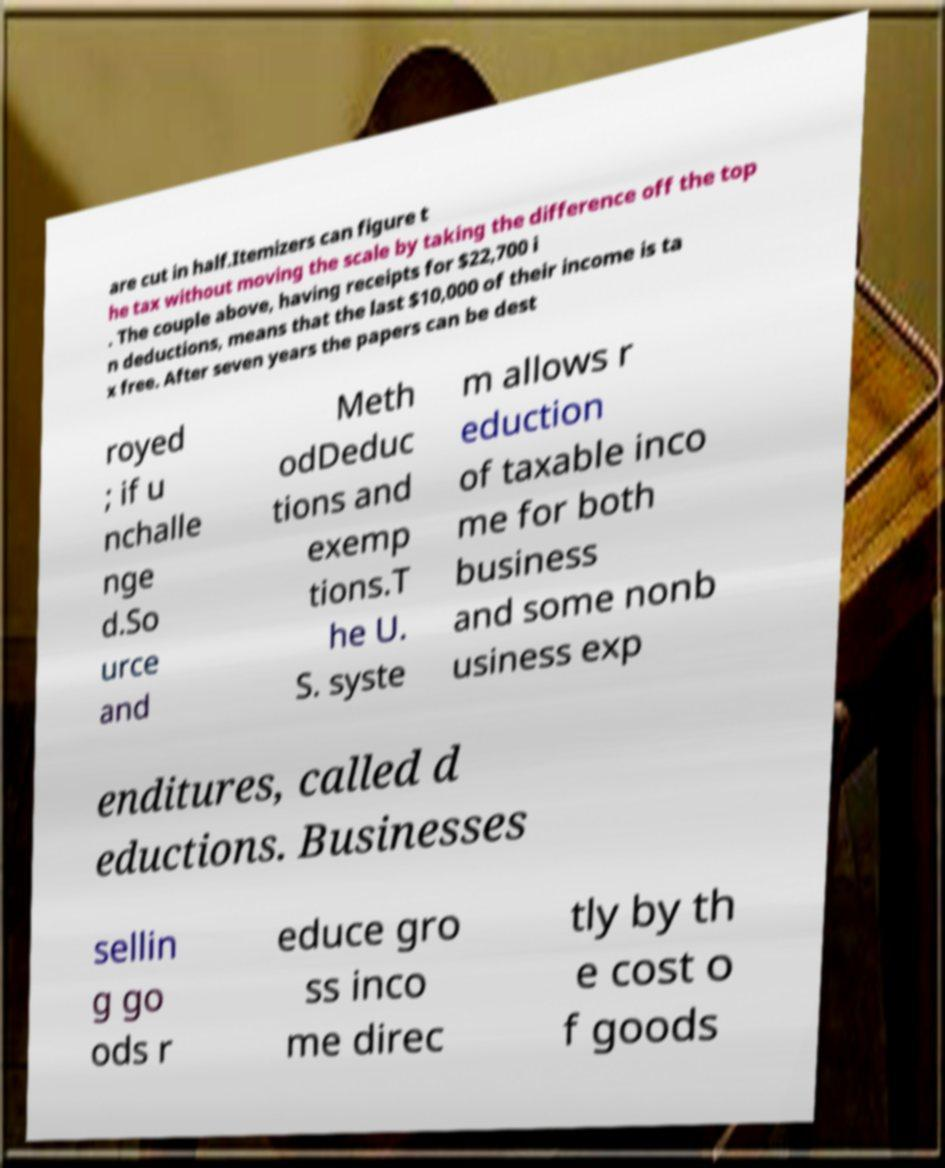Could you extract and type out the text from this image? are cut in half.Itemizers can figure t he tax without moving the scale by taking the difference off the top . The couple above, having receipts for $22,700 i n deductions, means that the last $10,000 of their income is ta x free. After seven years the papers can be dest royed ; if u nchalle nge d.So urce and Meth odDeduc tions and exemp tions.T he U. S. syste m allows r eduction of taxable inco me for both business and some nonb usiness exp enditures, called d eductions. Businesses sellin g go ods r educe gro ss inco me direc tly by th e cost o f goods 